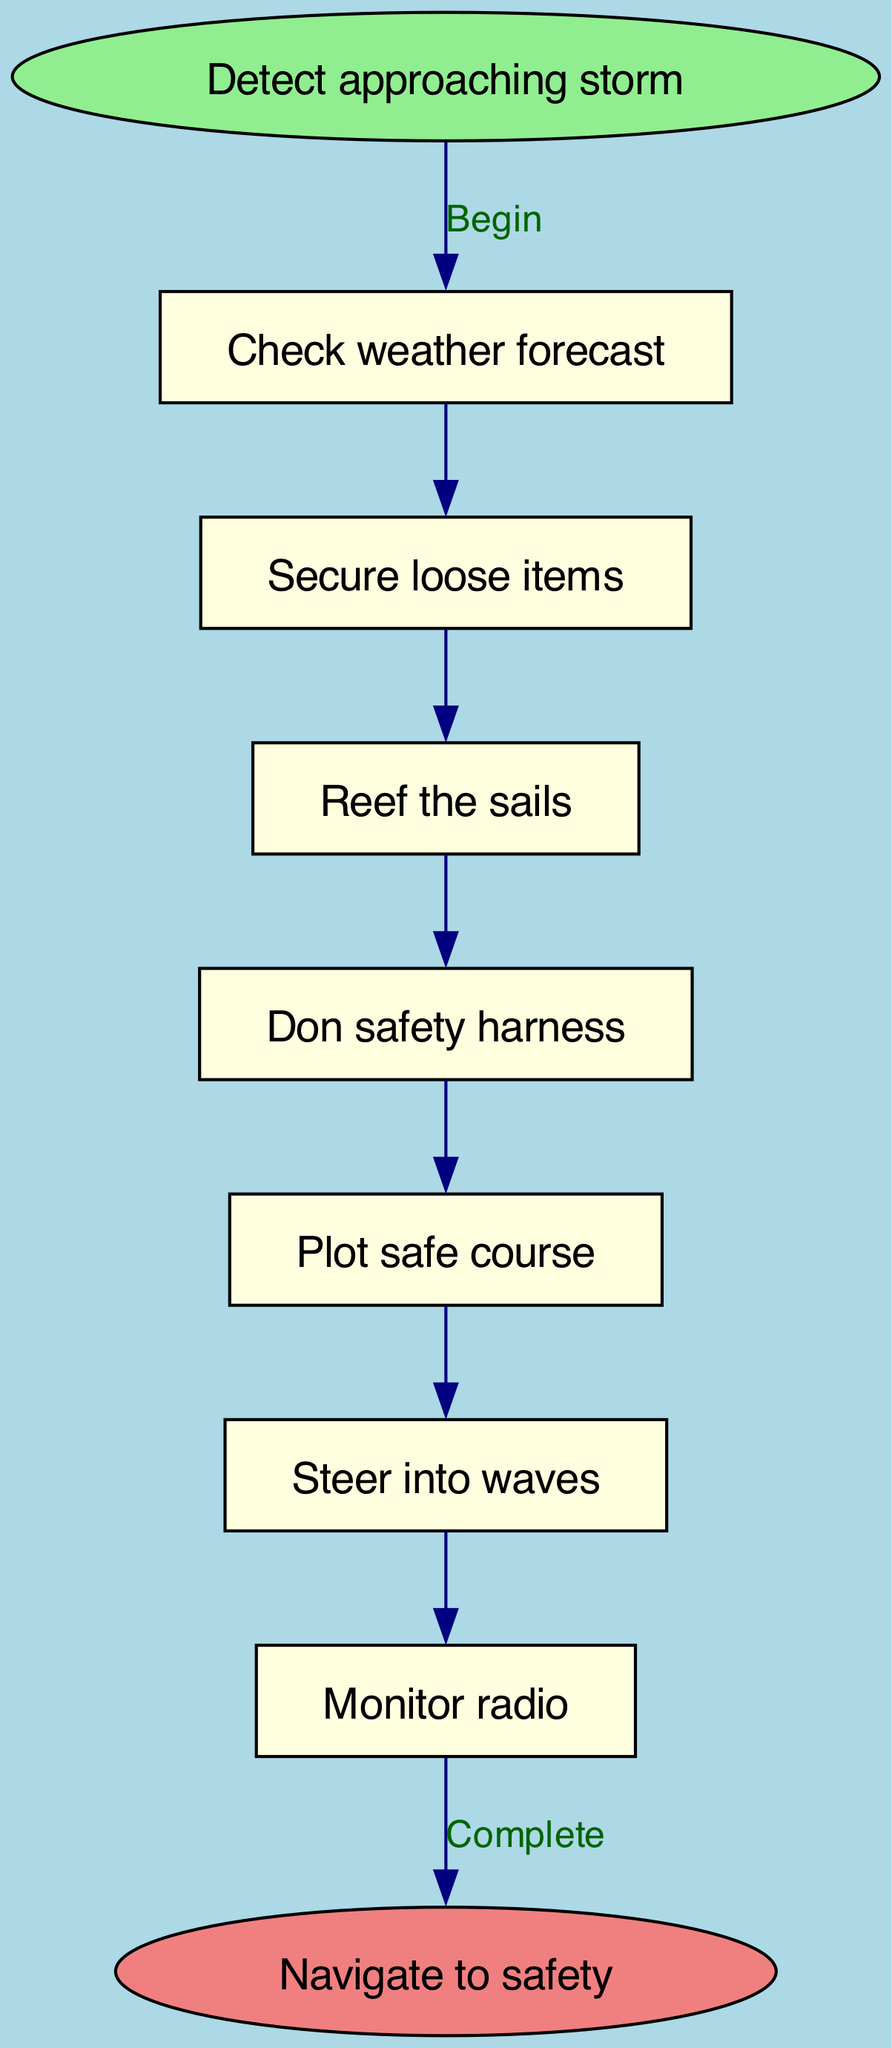What is the first action in the flow chart? The first action is indicated after the "Detect approaching storm" start node, which is "Check weather forecast."
Answer: Check weather forecast How many steps are there in total? The total number of steps can be counted by counting the individual actions listed in the flow structure shown; there are 7 steps noted before reaching the end.
Answer: 7 What is the last action before reaching safety? The action before reaching the "Navigate to safety" end node is "Adjust course as needed," which is directly linked as the final step of the navigation process.
Answer: Adjust course as needed What action follows after "Don safety harness"? Following the "Don safety harness" action, the next step indicated in the flow chart is "Plot safe course," which continues the sequence of actions to take during storm navigation.
Answer: Plot safe course Which action requires you to use a safety harness? The action specifically related to the safety harness requirement is "Don safety harness," where the sailor is instructed to put on the safety harness while preparing to navigate through the storm.
Answer: Don safety harness What action is taken immediately after securing loose items? After "Secure loose items," the next action is "Reef the sails," which emphasizes the importance of adjusting sail configurations for safer sailing during a storm.
Answer: Reef the sails How does the flow begin and end? The flow begins with "Detect approaching storm," leading through various steps and concludes with "Navigate to safety," indicating the start and endpoint of the storm navigation process.
Answer: Detect approaching storm, Navigate to safety 